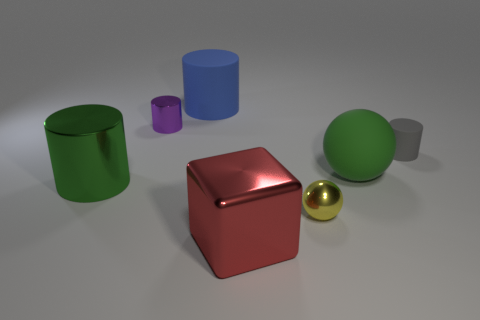Subtract 1 cylinders. How many cylinders are left? 3 Add 2 brown objects. How many objects exist? 9 Subtract all cylinders. How many objects are left? 3 Add 7 purple things. How many purple things exist? 8 Subtract 0 purple balls. How many objects are left? 7 Subtract all big gray rubber things. Subtract all big green metallic cylinders. How many objects are left? 6 Add 7 yellow metallic spheres. How many yellow metallic spheres are left? 8 